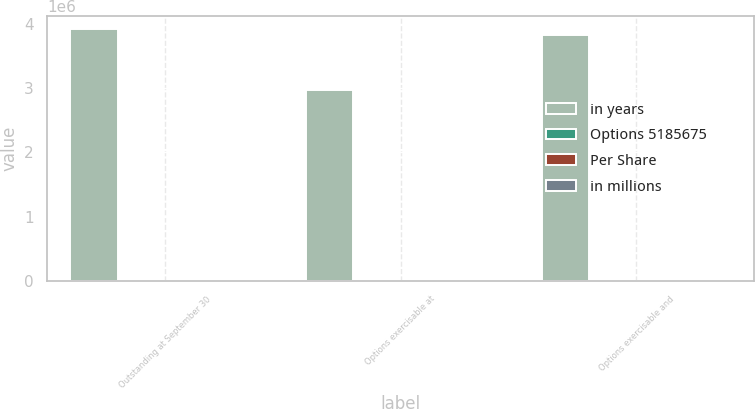<chart> <loc_0><loc_0><loc_500><loc_500><stacked_bar_chart><ecel><fcel>Outstanding at September 30<fcel>Options exercisable at<fcel>Options exercisable and<nl><fcel>in years<fcel>3.91721e+06<fcel>2.97342e+06<fcel>3.82283e+06<nl><fcel>Options 5185675<fcel>72.21<fcel>57.74<fcel>71.08<nl><fcel>Per Share<fcel>5.7<fcel>4.8<fcel>5.6<nl><fcel>in millions<fcel>466<fcel>397<fcel>459<nl></chart> 